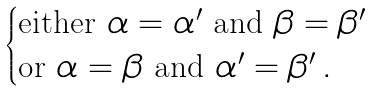Convert formula to latex. <formula><loc_0><loc_0><loc_500><loc_500>\begin{cases} \text {either } \alpha = \alpha ^ { \prime } \text   { and } \beta = \beta ^ { \prime } \\ \text {or } \alpha = \beta \text { and } \alpha ^ { \prime } = \beta ^ { \prime } \, . \end{cases}</formula> 